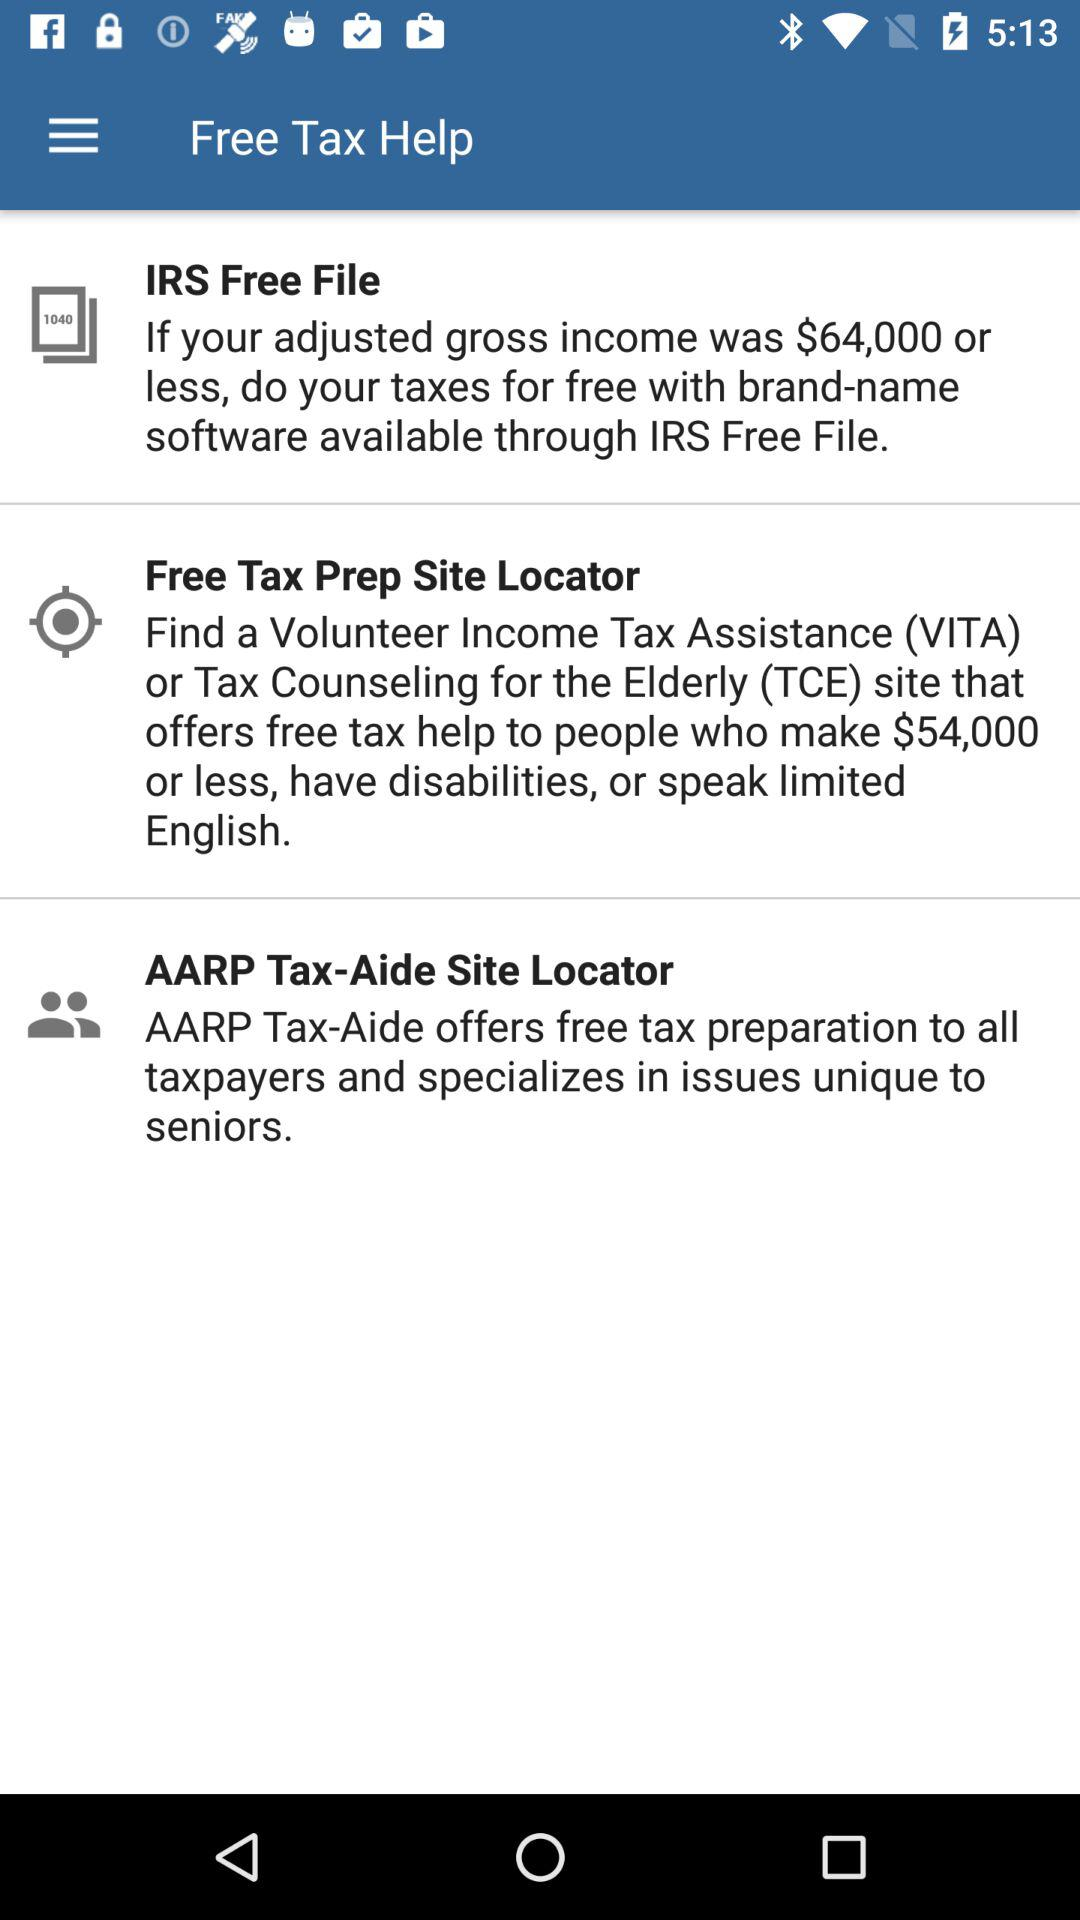How many tax preparation options are available?
Answer the question using a single word or phrase. 3 